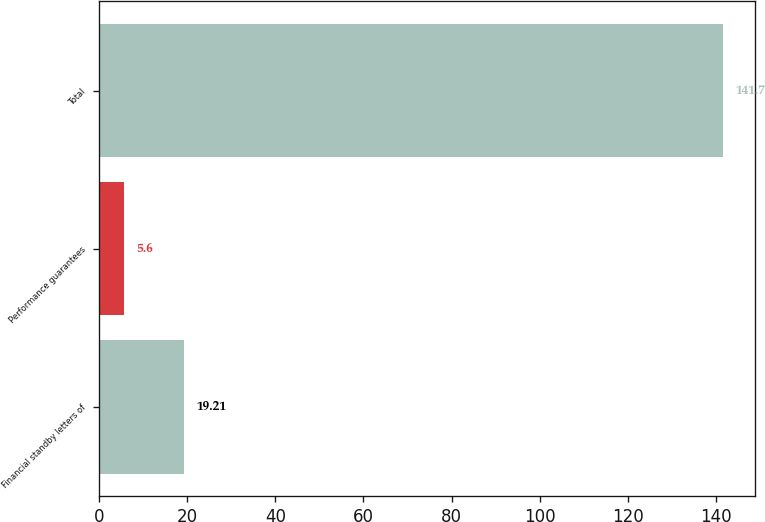Convert chart. <chart><loc_0><loc_0><loc_500><loc_500><bar_chart><fcel>Financial standby letters of<fcel>Performance guarantees<fcel>Total<nl><fcel>19.21<fcel>5.6<fcel>141.7<nl></chart> 